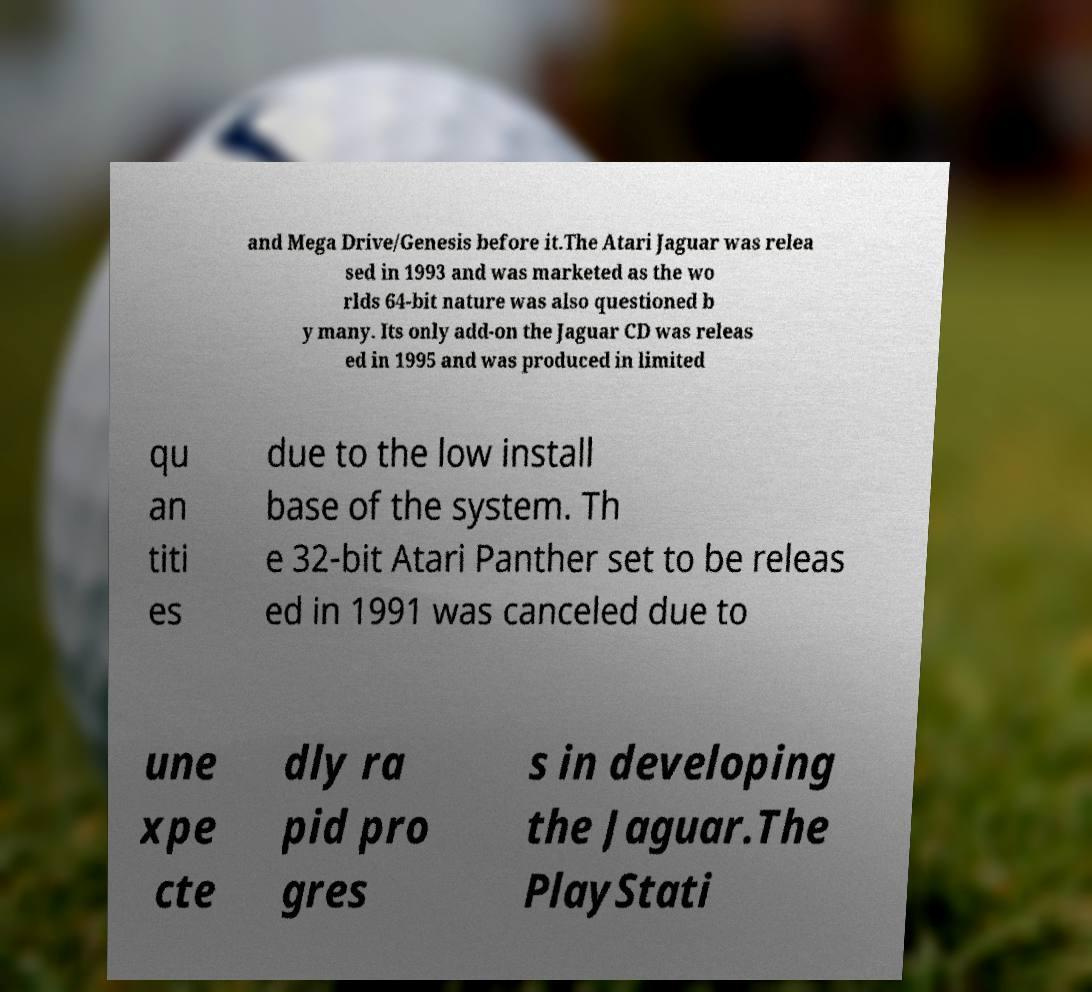Could you extract and type out the text from this image? and Mega Drive/Genesis before it.The Atari Jaguar was relea sed in 1993 and was marketed as the wo rlds 64-bit nature was also questioned b y many. Its only add-on the Jaguar CD was releas ed in 1995 and was produced in limited qu an titi es due to the low install base of the system. Th e 32-bit Atari Panther set to be releas ed in 1991 was canceled due to une xpe cte dly ra pid pro gres s in developing the Jaguar.The PlayStati 